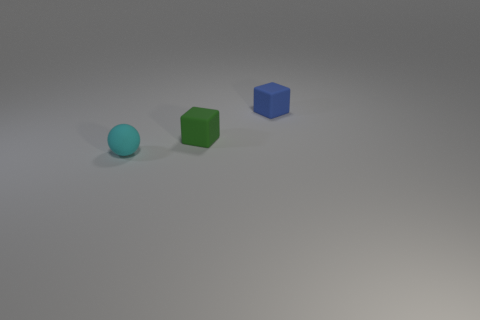Is there anything else that has the same shape as the cyan thing?
Provide a succinct answer. No. The object that is in front of the tiny green matte block has what shape?
Offer a terse response. Sphere. How many other matte things have the same shape as the green matte thing?
Provide a succinct answer. 1. What number of objects are either small blue cubes or red metallic cubes?
Ensure brevity in your answer.  1. What number of small blue things have the same material as the small cyan ball?
Make the answer very short. 1. Is the number of cyan rubber things less than the number of red rubber cubes?
Your answer should be very brief. No. What number of cubes are either tiny gray rubber objects or green matte objects?
Make the answer very short. 1. What color is the small matte ball left of the tiny cube that is behind the small rubber cube in front of the tiny blue cube?
Your answer should be compact. Cyan. Are there fewer small objects that are on the right side of the blue matte cube than blue blocks?
Your answer should be compact. Yes. Do the green thing that is in front of the small blue rubber thing and the small thing that is in front of the green block have the same shape?
Your response must be concise. No. 